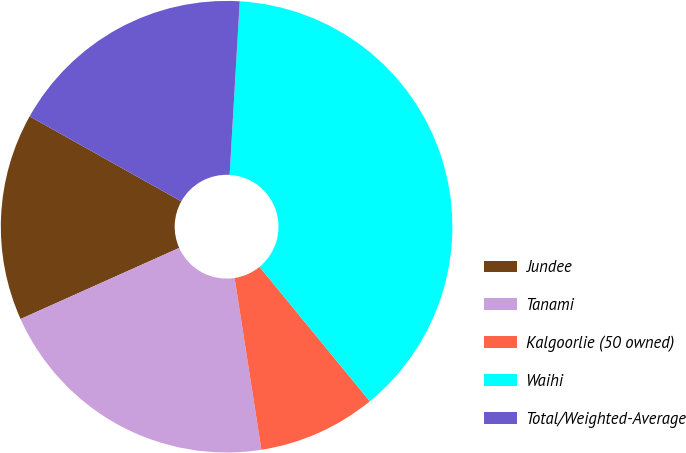Convert chart. <chart><loc_0><loc_0><loc_500><loc_500><pie_chart><fcel>Jundee<fcel>Tanami<fcel>Kalgoorlie (50 owned)<fcel>Waihi<fcel>Total/Weighted-Average<nl><fcel>14.83%<fcel>20.76%<fcel>8.47%<fcel>38.14%<fcel>17.8%<nl></chart> 